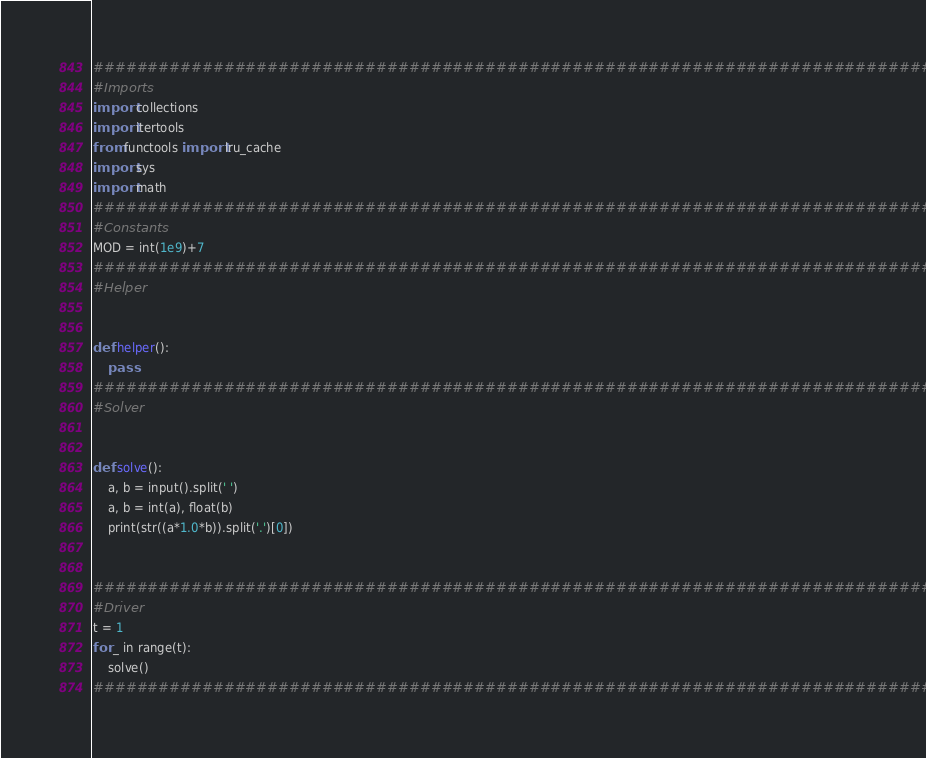Convert code to text. <code><loc_0><loc_0><loc_500><loc_500><_Python_>###############################################################################
#Imports
import collections
import itertools
from functools import lru_cache
import sys
import math
###############################################################################
#Constants
MOD = int(1e9)+7
###############################################################################
#Helper


def helper():
	pass
###############################################################################
#Solver


def solve():
	a, b = input().split(' ')
	a, b = int(a), float(b)
	print(str((a*1.0*b)).split('.')[0])


###############################################################################
#Driver
t = 1
for _ in range(t):
	solve()
###############################################################################
</code> 